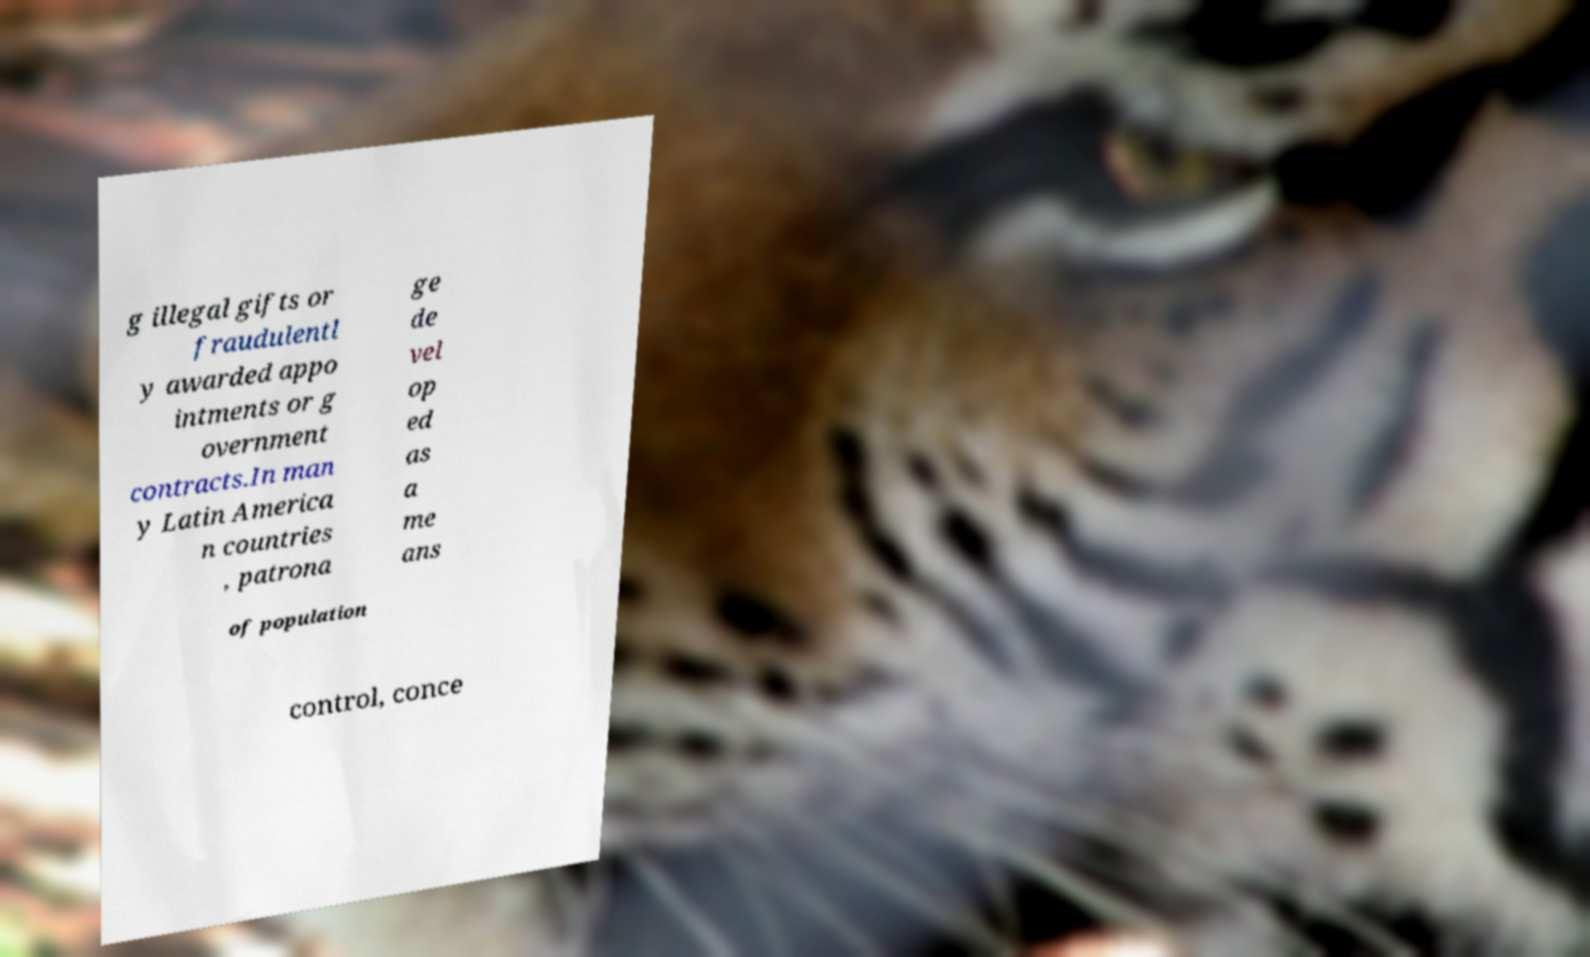Can you read and provide the text displayed in the image?This photo seems to have some interesting text. Can you extract and type it out for me? g illegal gifts or fraudulentl y awarded appo intments or g overnment contracts.In man y Latin America n countries , patrona ge de vel op ed as a me ans of population control, conce 